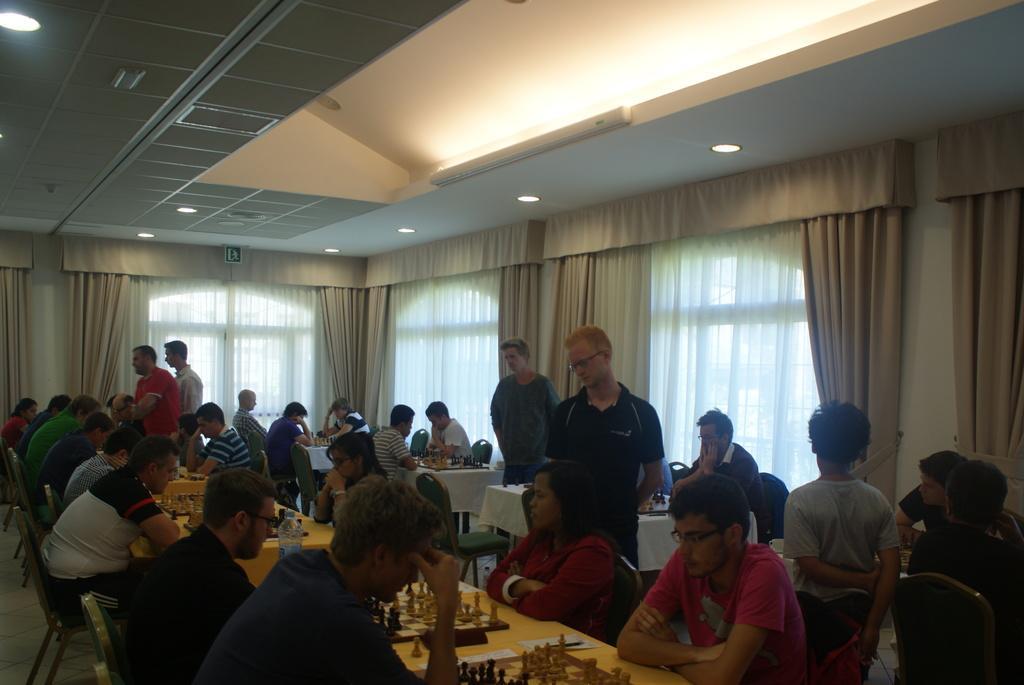Can you describe this image briefly? This picture is of inside the room. In the foreground there are group of persons sitting on the chairs and playing chess which is placed on the top of the table. There is a man wearing black color t-shirt and standing. On the right there is a person standing. In the background we can see the two person standing and group of persons sitting on the chairs and playing chess. We can see the curtains and on the top there is a roof and the ceiling lights. 